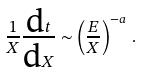<formula> <loc_0><loc_0><loc_500><loc_500>\frac { 1 } { X } \frac { \text {d} t } { \text {d} X } \sim \left ( \frac { E } { X } \right ) ^ { - a } \, .</formula> 